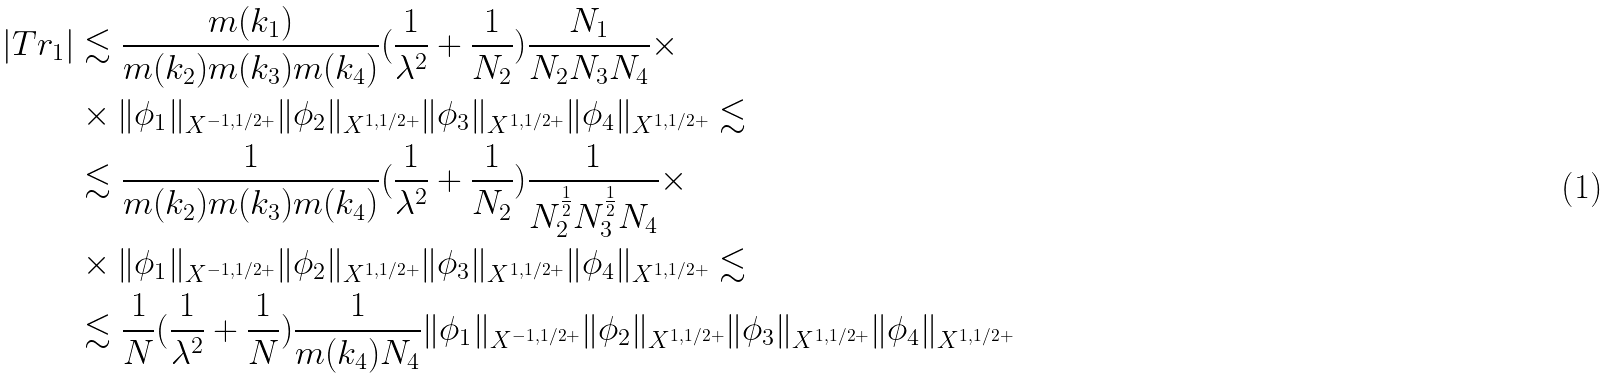Convert formula to latex. <formula><loc_0><loc_0><loc_500><loc_500>| T r _ { 1 } | & \lesssim \frac { m ( k _ { 1 } ) } { m ( k _ { 2 } ) m ( k _ { 3 } ) m ( k _ { 4 } ) } ( \frac { 1 } { \lambda ^ { 2 } } + \frac { 1 } { N _ { 2 } } ) \frac { N _ { 1 } } { N _ { 2 } N _ { 3 } N _ { 4 } } \times \\ & \times \| \phi _ { 1 } \| _ { X ^ { - 1 , 1 / 2 + } } \| \phi _ { 2 } \| _ { X ^ { 1 , 1 / 2 + } } \| \phi _ { 3 } \| _ { X ^ { 1 , 1 / 2 + } } \| \phi _ { 4 } \| _ { X ^ { 1 , 1 / 2 + } } \lesssim \\ & \lesssim \frac { 1 } { m ( k _ { 2 } ) m ( k _ { 3 } ) m ( k _ { 4 } ) } ( \frac { 1 } { \lambda ^ { 2 } } + \frac { 1 } { N _ { 2 } } ) \frac { 1 } { N _ { 2 } ^ { \frac { 1 } { 2 } } N _ { 3 } ^ { \frac { 1 } { 2 } } N _ { 4 } } \times \\ & \times \| \phi _ { 1 } \| _ { X ^ { - 1 , 1 / 2 + } } \| \phi _ { 2 } \| _ { X ^ { 1 , 1 / 2 + } } \| \phi _ { 3 } \| _ { X ^ { 1 , 1 / 2 + } } \| \phi _ { 4 } \| _ { X ^ { 1 , 1 / 2 + } } \lesssim \\ & \lesssim \frac { 1 } { N } ( \frac { 1 } { \lambda ^ { 2 } } + \frac { 1 } { N } ) \frac { 1 } { m ( k _ { 4 } ) N _ { 4 } } \| \phi _ { 1 } \| _ { X ^ { - 1 , 1 / 2 + } } \| \phi _ { 2 } \| _ { X ^ { 1 , 1 / 2 + } } \| \phi _ { 3 } \| _ { X ^ { 1 , 1 / 2 + } } \| \phi _ { 4 } \| _ { X ^ { 1 , 1 / 2 + } }</formula> 